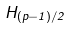Convert formula to latex. <formula><loc_0><loc_0><loc_500><loc_500>H _ { ( p - 1 ) / 2 }</formula> 